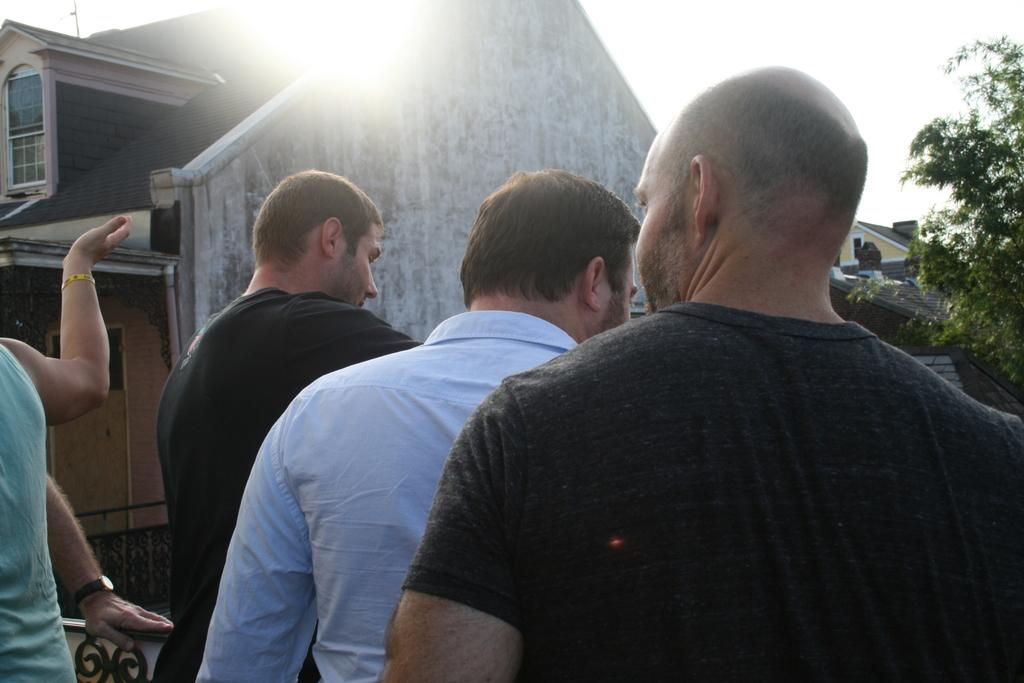Who or what can be seen in the image? There are people in the image. What structures are visible in the background of the image? There are houses in the background of the image. What type of natural elements can be seen in the background of the image? There are trees in the background of the image. What is visible in the sky in the background of the image? The sky is visible in the background of the image. What type of coal can be seen being transported by the pigs in the image? There are no pigs or coal present in the image. What sound can be heard coming from the houses in the image? The image is a still picture, so no sound can be heard. 